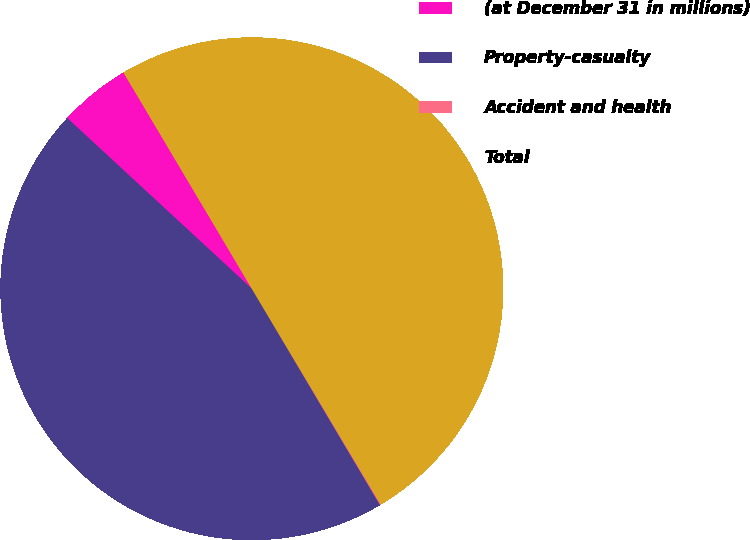Convert chart to OTSL. <chart><loc_0><loc_0><loc_500><loc_500><pie_chart><fcel>(at December 31 in millions)<fcel>Property-casualty<fcel>Accident and health<fcel>Total<nl><fcel>4.6%<fcel>45.4%<fcel>0.06%<fcel>49.94%<nl></chart> 